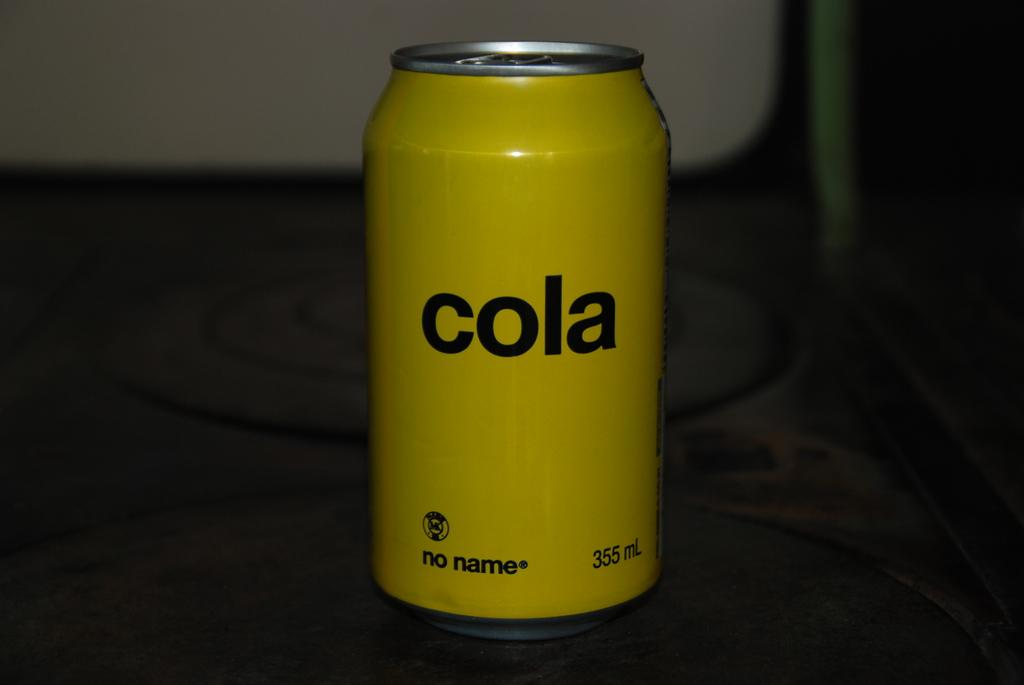<image>
Summarize the visual content of the image. A single plain yellow can with the label "cola" is on the table. 